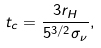Convert formula to latex. <formula><loc_0><loc_0><loc_500><loc_500>t _ { c } = \frac { 3 r _ { H } } { 5 ^ { 3 / 2 } \sigma _ { \nu } } ,</formula> 